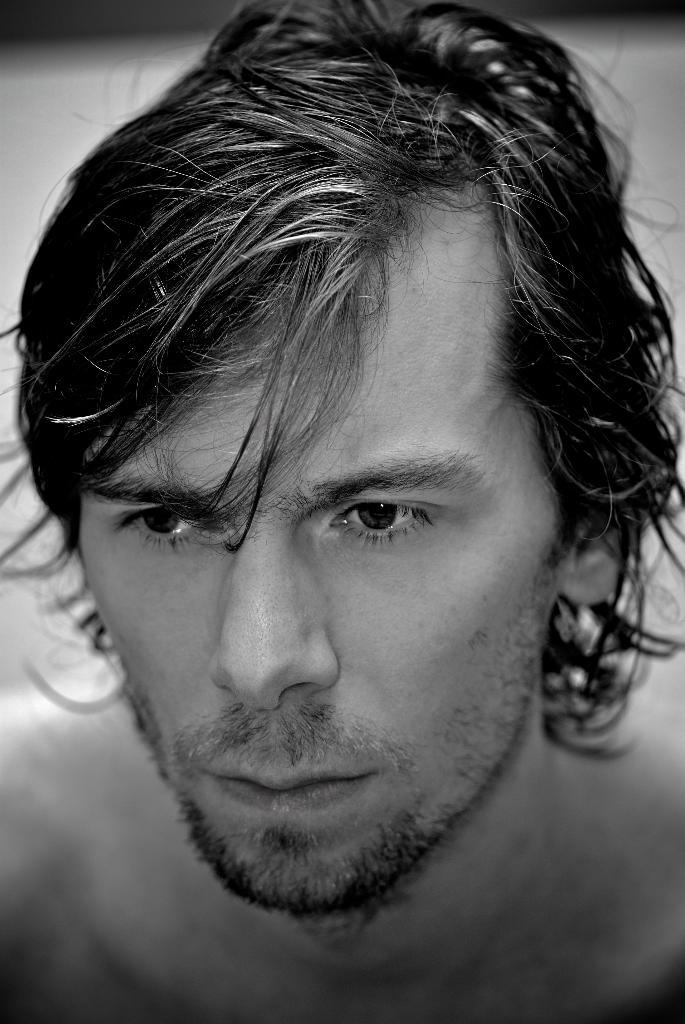What is the main subject of the image? There is a man in the image. What type of key is the man holding in the image? There is no key present in the image; it only features a man. Can you describe the map that the man is using in the image? There is no map present in the image; it only features a man. 